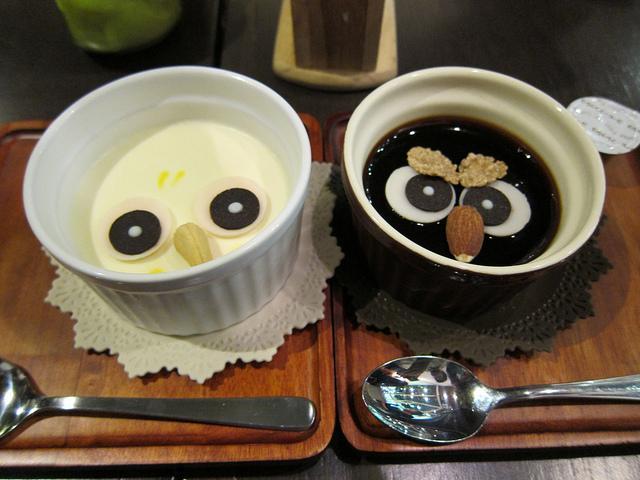How many cups of food are on the trays?
Give a very brief answer. 2. How many spoons are in the photo?
Give a very brief answer. 2. How many bowls are in the photo?
Give a very brief answer. 2. How many donuts are in the box?
Give a very brief answer. 0. 